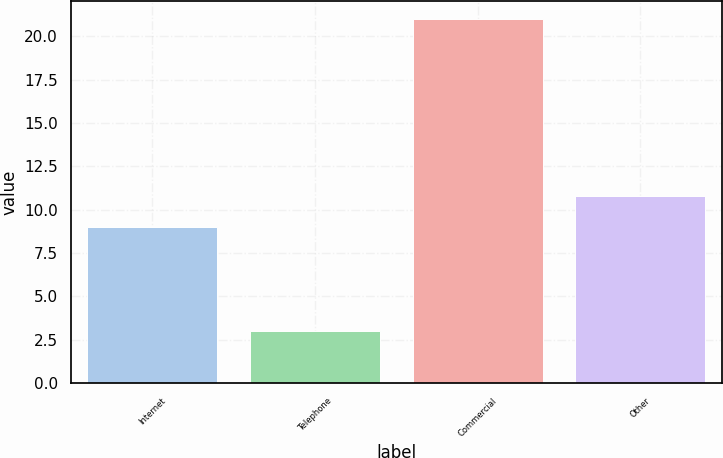Convert chart. <chart><loc_0><loc_0><loc_500><loc_500><bar_chart><fcel>Internet<fcel>Telephone<fcel>Commercial<fcel>Other<nl><fcel>9<fcel>3<fcel>21<fcel>10.8<nl></chart> 